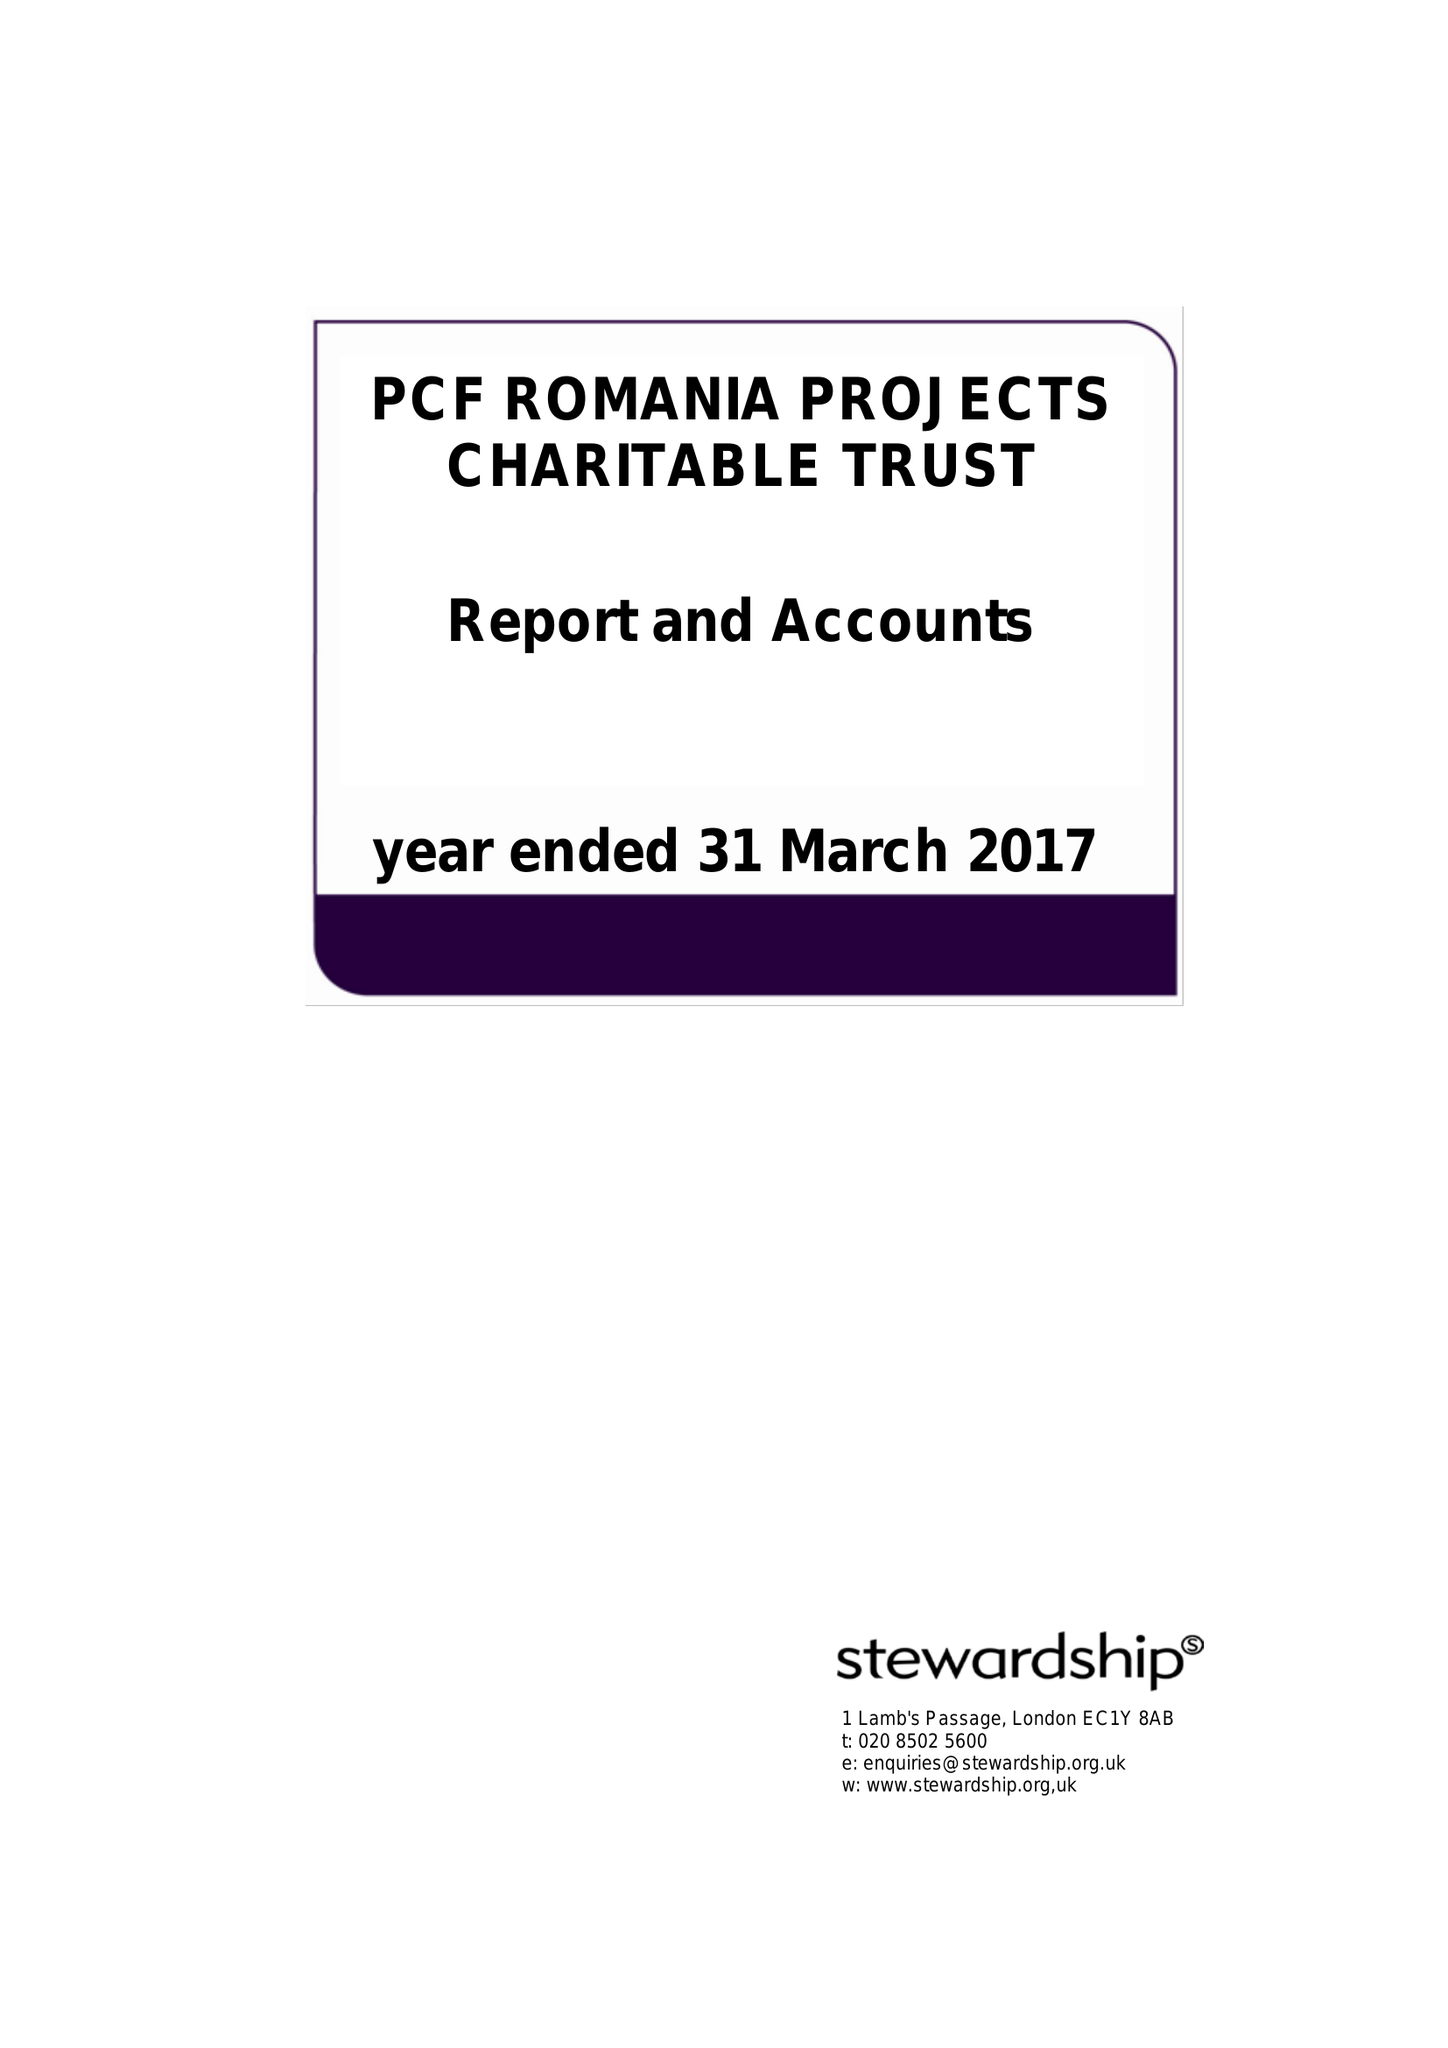What is the value for the address__post_town?
Answer the question using a single word or phrase. WOLVERHAMPTON 